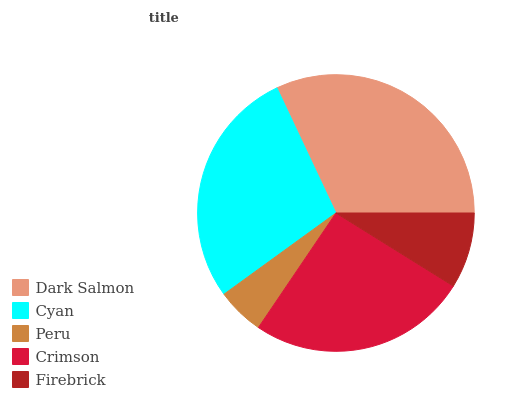Is Peru the minimum?
Answer yes or no. Yes. Is Dark Salmon the maximum?
Answer yes or no. Yes. Is Cyan the minimum?
Answer yes or no. No. Is Cyan the maximum?
Answer yes or no. No. Is Dark Salmon greater than Cyan?
Answer yes or no. Yes. Is Cyan less than Dark Salmon?
Answer yes or no. Yes. Is Cyan greater than Dark Salmon?
Answer yes or no. No. Is Dark Salmon less than Cyan?
Answer yes or no. No. Is Crimson the high median?
Answer yes or no. Yes. Is Crimson the low median?
Answer yes or no. Yes. Is Peru the high median?
Answer yes or no. No. Is Peru the low median?
Answer yes or no. No. 